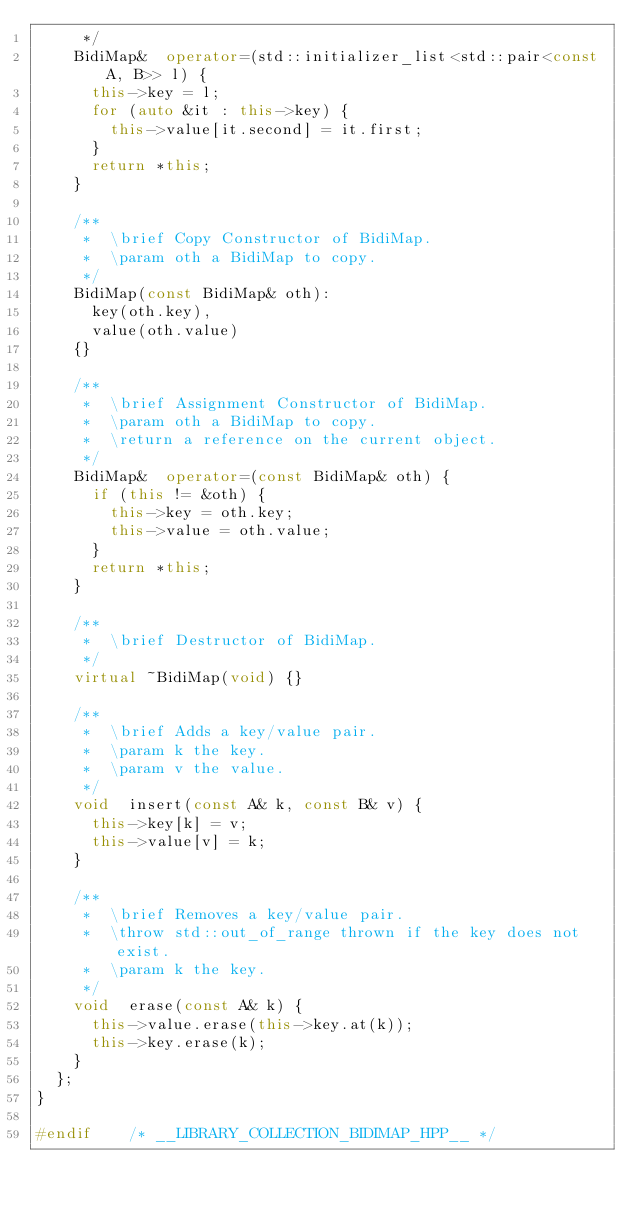Convert code to text. <code><loc_0><loc_0><loc_500><loc_500><_C++_>     */
    BidiMap&  operator=(std::initializer_list<std::pair<const A, B>> l) {
      this->key = l;
      for (auto &it : this->key) {
        this->value[it.second] = it.first;
      }
      return *this;
    }

    /**
     *  \brief Copy Constructor of BidiMap.
     *  \param oth a BidiMap to copy.
     */
    BidiMap(const BidiMap& oth):
      key(oth.key),
      value(oth.value)
    {}

    /**
     *  \brief Assignment Constructor of BidiMap.
     *  \param oth a BidiMap to copy.
     *  \return a reference on the current object.
     */
    BidiMap&  operator=(const BidiMap& oth) {
      if (this != &oth) {
        this->key = oth.key;
        this->value = oth.value;
      }
      return *this;
    }

    /**
     *  \brief Destructor of BidiMap.
     */
    virtual ~BidiMap(void) {}

    /**
     *  \brief Adds a key/value pair.
     *  \param k the key.
     *  \param v the value.
     */
    void  insert(const A& k, const B& v) {
      this->key[k] = v;
      this->value[v] = k;
    }

    /**
     *  \brief Removes a key/value pair.
     *  \throw std::out_of_range thrown if the key does not exist.
     *  \param k the key.
     */
    void  erase(const A& k) {
      this->value.erase(this->key.at(k));
      this->key.erase(k);
    }
  };
}

#endif    /* __LIBRARY_COLLECTION_BIDIMAP_HPP__ */
</code> 